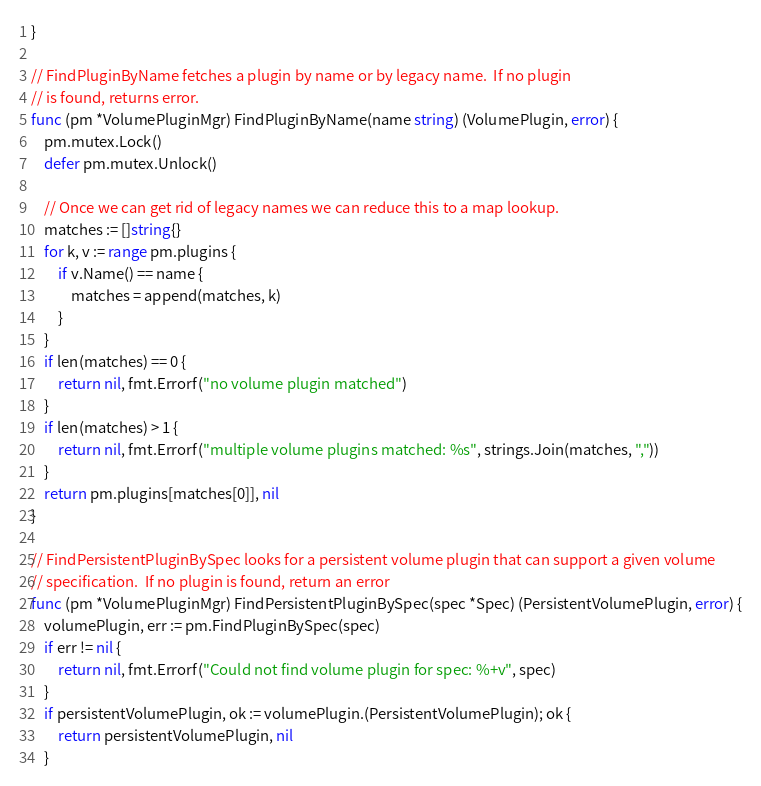<code> <loc_0><loc_0><loc_500><loc_500><_Go_>}

// FindPluginByName fetches a plugin by name or by legacy name.  If no plugin
// is found, returns error.
func (pm *VolumePluginMgr) FindPluginByName(name string) (VolumePlugin, error) {
	pm.mutex.Lock()
	defer pm.mutex.Unlock()

	// Once we can get rid of legacy names we can reduce this to a map lookup.
	matches := []string{}
	for k, v := range pm.plugins {
		if v.Name() == name {
			matches = append(matches, k)
		}
	}
	if len(matches) == 0 {
		return nil, fmt.Errorf("no volume plugin matched")
	}
	if len(matches) > 1 {
		return nil, fmt.Errorf("multiple volume plugins matched: %s", strings.Join(matches, ","))
	}
	return pm.plugins[matches[0]], nil
}

// FindPersistentPluginBySpec looks for a persistent volume plugin that can support a given volume
// specification.  If no plugin is found, return an error
func (pm *VolumePluginMgr) FindPersistentPluginBySpec(spec *Spec) (PersistentVolumePlugin, error) {
	volumePlugin, err := pm.FindPluginBySpec(spec)
	if err != nil {
		return nil, fmt.Errorf("Could not find volume plugin for spec: %+v", spec)
	}
	if persistentVolumePlugin, ok := volumePlugin.(PersistentVolumePlugin); ok {
		return persistentVolumePlugin, nil
	}</code> 